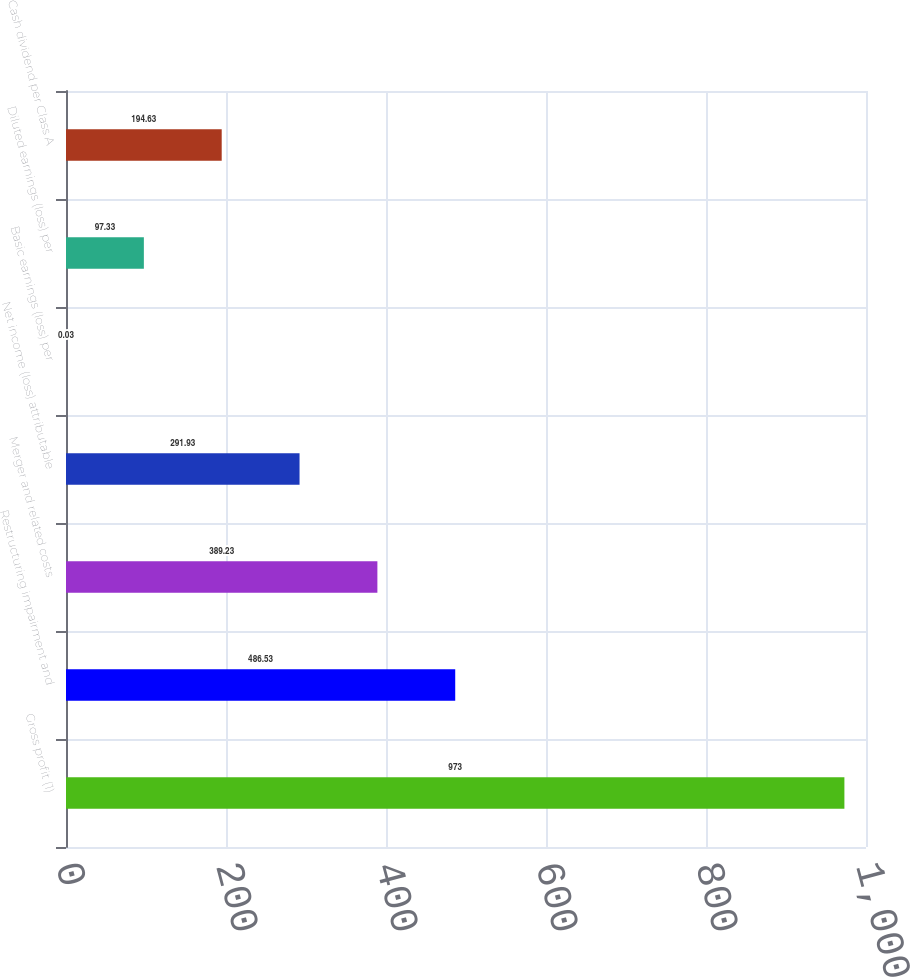Convert chart. <chart><loc_0><loc_0><loc_500><loc_500><bar_chart><fcel>Gross profit (1)<fcel>Restructuring impairment and<fcel>Merger and related costs<fcel>Net income (loss) attributable<fcel>Basic earnings (loss) per<fcel>Diluted earnings (loss) per<fcel>Cash dividend per Class A<nl><fcel>973<fcel>486.53<fcel>389.23<fcel>291.93<fcel>0.03<fcel>97.33<fcel>194.63<nl></chart> 